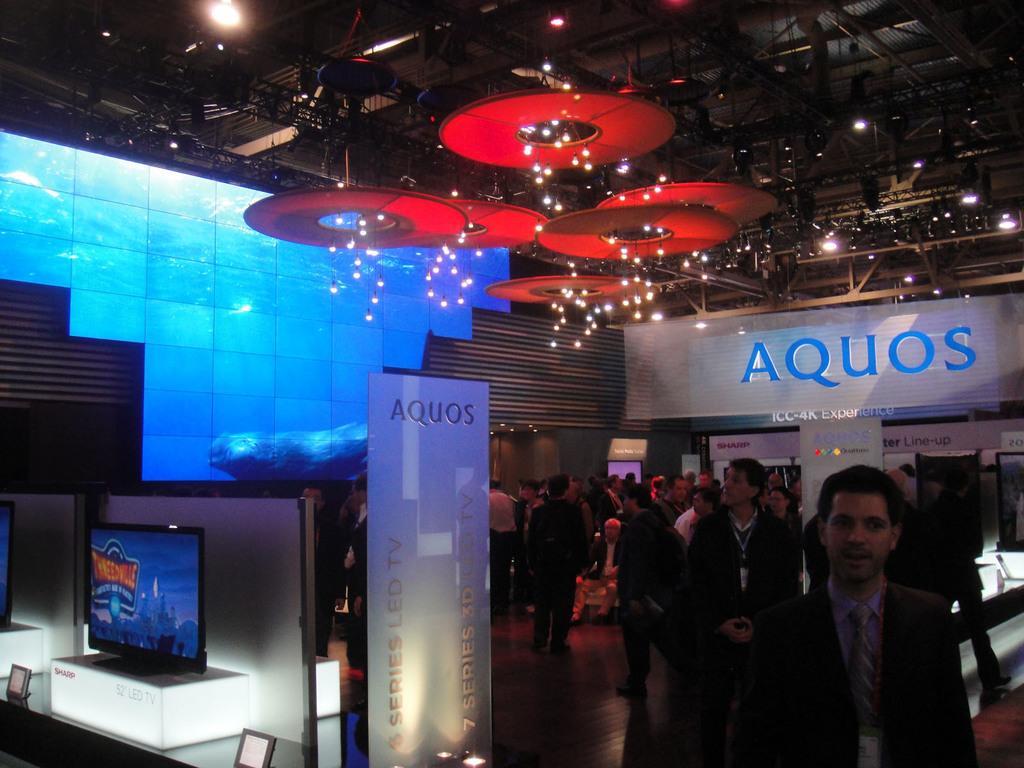In one or two sentences, can you explain what this image depicts? In this image I can see the group of people standing. And these people are wearing the different color dresses. To the side of these people I can see the banner and the systems. The systems are on the table. In the back I can see the wall and I can see few lights and roof in the top. 